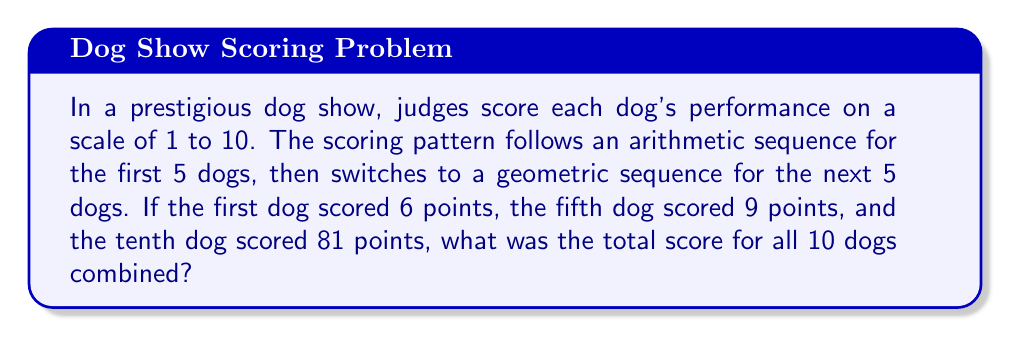Solve this math problem. Let's break this down step by step:

1) First, let's analyze the arithmetic sequence for the first 5 dogs:
   - We know the first term $a_1 = 6$ and the fifth term $a_5 = 9$
   - In an arithmetic sequence, the common difference $d$ is constant:
     $$d = \frac{a_5 - a_1}{5-1} = \frac{9-6}{4} = \frac{3}{4} = 0.75$$
   - The sequence for the first 5 dogs is: $6, 6.75, 7.5, 8.25, 9$
   - Sum of this arithmetic sequence: $S_1 = \frac{n(a_1 + a_n)}{2} = \frac{5(6 + 9)}{2} = 37.5$

2) Now, let's analyze the geometric sequence for the next 5 dogs:
   - We know the first term of this sequence (6th dog overall) $b_1 = 9$ and the fifth term $b_5 = 81$
   - In a geometric sequence, the common ratio $r$ is constant:
     $$r = \sqrt[4]{\frac{b_5}{b_1}} = \sqrt[4]{\frac{81}{9}} = \sqrt[4]{9} = \sqrt{3} \approx 1.732$$
   - The sequence for the next 5 dogs is: $9, 15.59, 27, 46.77, 81$
   - Sum of this geometric sequence: $S_2 = \frac{b_1(1-r^n)}{1-r} = \frac{9(1-(\sqrt{3})^5)}{1-\sqrt{3}} \approx 179.36$

3) The total score is the sum of both sequences:
   $$\text{Total Score} = S_1 + S_2 = 37.5 + 179.36 = 216.86$$

Therefore, the total score for all 10 dogs combined is approximately 216.86 points.
Answer: 216.86 points 